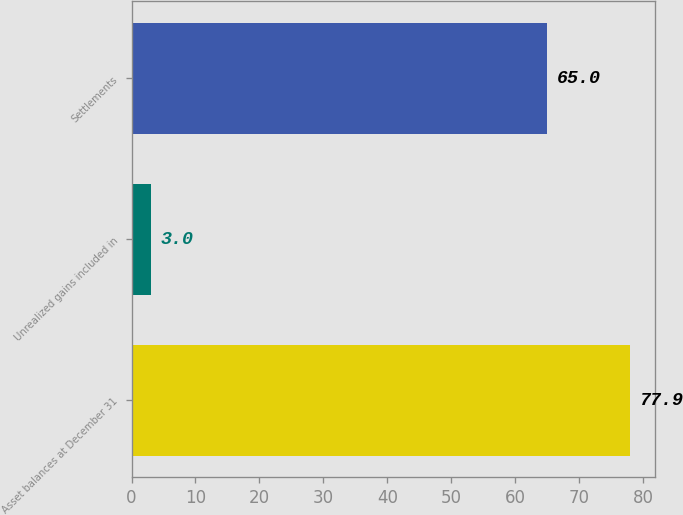Convert chart to OTSL. <chart><loc_0><loc_0><loc_500><loc_500><bar_chart><fcel>Asset balances at December 31<fcel>Unrealized gains included in<fcel>Settlements<nl><fcel>77.9<fcel>3<fcel>65<nl></chart> 